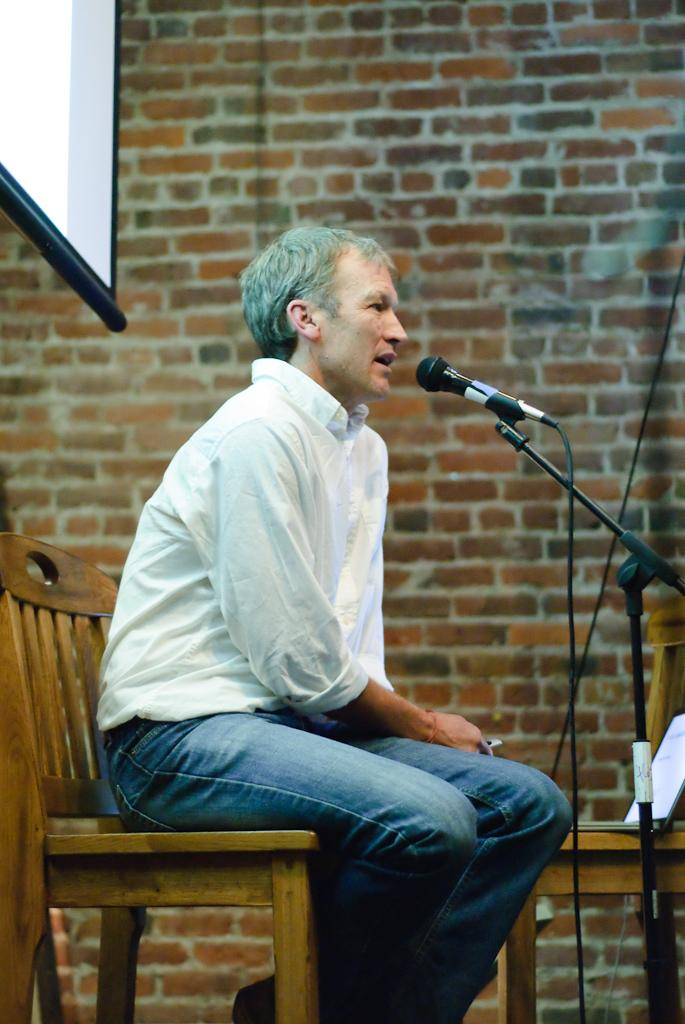What is the man in the image doing? The man is sitting in a chair and talking into a microphone. What can be seen behind the man in the image? There is a screen, a book, and a wall in the background of the image. How does the man control the heat in the image? There is no mention of heat or any device to control it in the image. 